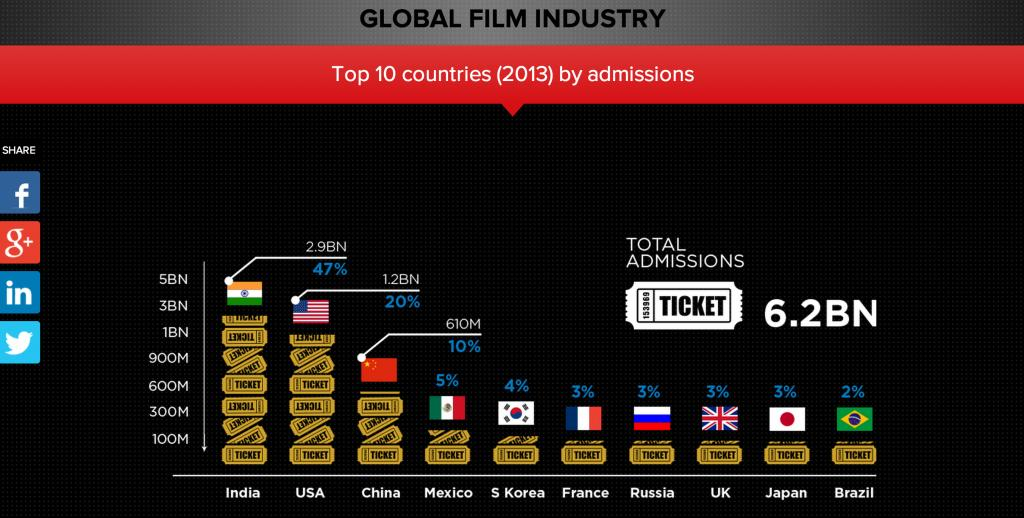Give some essential details in this illustration. In 2013, a total of 1.2 billion ticket admissions were recorded globally, and the United States accounted for the majority of these admissions with the highest number of tickets sold. In the year 2013, approximately 47% of total movie admissions worldwide were from India. In total, 4.1 billion tickets were sold in India and the United States combined. South Korea contributed 4% of the total number of movie admissions. China made a sale of tickets nearly equal to half of the tickets sold in the USA. 